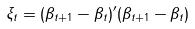<formula> <loc_0><loc_0><loc_500><loc_500>\xi _ { t } = ( \beta _ { t + 1 } - \beta _ { t } ) ^ { \prime } ( \beta _ { t + 1 } - \beta _ { t } )</formula> 